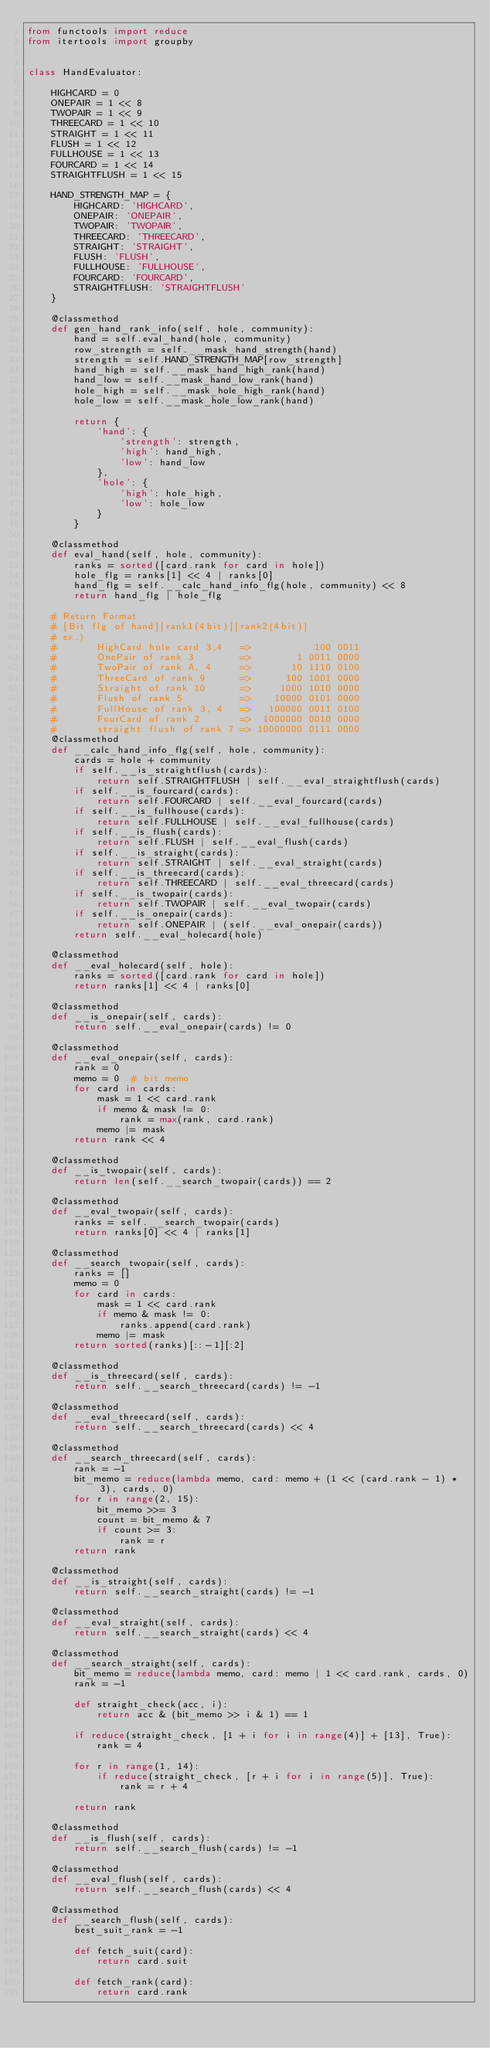<code> <loc_0><loc_0><loc_500><loc_500><_Python_>from functools import reduce
from itertools import groupby


class HandEvaluator:

    HIGHCARD = 0
    ONEPAIR = 1 << 8
    TWOPAIR = 1 << 9
    THREECARD = 1 << 10
    STRAIGHT = 1 << 11
    FLUSH = 1 << 12
    FULLHOUSE = 1 << 13
    FOURCARD = 1 << 14
    STRAIGHTFLUSH = 1 << 15

    HAND_STRENGTH_MAP = {
        HIGHCARD: 'HIGHCARD',
        ONEPAIR: 'ONEPAIR',
        TWOPAIR: 'TWOPAIR',
        THREECARD: 'THREECARD',
        STRAIGHT: 'STRAIGHT',
        FLUSH: 'FLUSH',
        FULLHOUSE: 'FULLHOUSE',
        FOURCARD: 'FOURCARD',
        STRAIGHTFLUSH: 'STRAIGHTFLUSH'
    }

    @classmethod
    def gen_hand_rank_info(self, hole, community):
        hand = self.eval_hand(hole, community)
        row_strength = self.__mask_hand_strength(hand)
        strength = self.HAND_STRENGTH_MAP[row_strength]
        hand_high = self.__mask_hand_high_rank(hand)
        hand_low = self.__mask_hand_low_rank(hand)
        hole_high = self.__mask_hole_high_rank(hand)
        hole_low = self.__mask_hole_low_rank(hand)

        return {
            'hand': {
                'strength': strength,
                'high': hand_high,
                'low': hand_low
            },
            'hole': {
                'high': hole_high,
                'low': hole_low
            }
        }

    @classmethod
    def eval_hand(self, hole, community):
        ranks = sorted([card.rank for card in hole])
        hole_flg = ranks[1] << 4 | ranks[0]
        hand_flg = self.__calc_hand_info_flg(hole, community) << 8
        return hand_flg | hole_flg

    # Return Format
    # [Bit flg of hand][rank1(4bit)][rank2(4bit)]
    # ex.)
    #       HighCard hole card 3,4   =>           100 0011
    #       OnePair of rank 3        =>        1 0011 0000
    #       TwoPair of rank A, 4     =>       10 1110 0100
    #       ThreeCard of rank 9      =>      100 1001 0000
    #       Straight of rank 10      =>     1000 1010 0000
    #       Flush of rank 5          =>    10000 0101 0000
    #       FullHouse of rank 3, 4   =>   100000 0011 0100
    #       FourCard of rank 2       =>  1000000 0010 0000
    #       straight flush of rank 7 => 10000000 0111 0000
    @classmethod
    def __calc_hand_info_flg(self, hole, community):
        cards = hole + community
        if self.__is_straightflush(cards):
            return self.STRAIGHTFLUSH | self.__eval_straightflush(cards)
        if self.__is_fourcard(cards):
            return self.FOURCARD | self.__eval_fourcard(cards)
        if self.__is_fullhouse(cards):
            return self.FULLHOUSE | self.__eval_fullhouse(cards)
        if self.__is_flush(cards):
            return self.FLUSH | self.__eval_flush(cards)
        if self.__is_straight(cards):
            return self.STRAIGHT | self.__eval_straight(cards)
        if self.__is_threecard(cards):
            return self.THREECARD | self.__eval_threecard(cards)
        if self.__is_twopair(cards):
            return self.TWOPAIR | self.__eval_twopair(cards)
        if self.__is_onepair(cards):
            return self.ONEPAIR | (self.__eval_onepair(cards))
        return self.__eval_holecard(hole)

    @classmethod
    def __eval_holecard(self, hole):
        ranks = sorted([card.rank for card in hole])
        return ranks[1] << 4 | ranks[0]

    @classmethod
    def __is_onepair(self, cards):
        return self.__eval_onepair(cards) != 0

    @classmethod
    def __eval_onepair(self, cards):
        rank = 0
        memo = 0  # bit memo
        for card in cards:
            mask = 1 << card.rank
            if memo & mask != 0:
                rank = max(rank, card.rank)
            memo |= mask
        return rank << 4

    @classmethod
    def __is_twopair(self, cards):
        return len(self.__search_twopair(cards)) == 2

    @classmethod
    def __eval_twopair(self, cards):
        ranks = self.__search_twopair(cards)
        return ranks[0] << 4 | ranks[1]

    @classmethod
    def __search_twopair(self, cards):
        ranks = []
        memo = 0
        for card in cards:
            mask = 1 << card.rank
            if memo & mask != 0:
                ranks.append(card.rank)
            memo |= mask
        return sorted(ranks)[::-1][:2]

    @classmethod
    def __is_threecard(self, cards):
        return self.__search_threecard(cards) != -1

    @classmethod
    def __eval_threecard(self, cards):
        return self.__search_threecard(cards) << 4

    @classmethod
    def __search_threecard(self, cards):
        rank = -1
        bit_memo = reduce(lambda memo, card: memo + (1 << (card.rank - 1) * 3), cards, 0)
        for r in range(2, 15):
            bit_memo >>= 3
            count = bit_memo & 7
            if count >= 3:
                rank = r
        return rank

    @classmethod
    def __is_straight(self, cards):
        return self.__search_straight(cards) != -1

    @classmethod
    def __eval_straight(self, cards):
        return self.__search_straight(cards) << 4

    @classmethod
    def __search_straight(self, cards):
        bit_memo = reduce(lambda memo, card: memo | 1 << card.rank, cards, 0)
        rank = -1

        def straight_check(acc, i):
            return acc & (bit_memo >> i & 1) == 1

        if reduce(straight_check, [1 + i for i in range(4)] + [13], True):
            rank = 4

        for r in range(1, 14):
            if reduce(straight_check, [r + i for i in range(5)], True):
                rank = r + 4

        return rank

    @classmethod
    def __is_flush(self, cards):
        return self.__search_flush(cards) != -1

    @classmethod
    def __eval_flush(self, cards):
        return self.__search_flush(cards) << 4

    @classmethod
    def __search_flush(self, cards):
        best_suit_rank = -1

        def fetch_suit(card):
            return card.suit

        def fetch_rank(card):
            return card.rank
</code> 